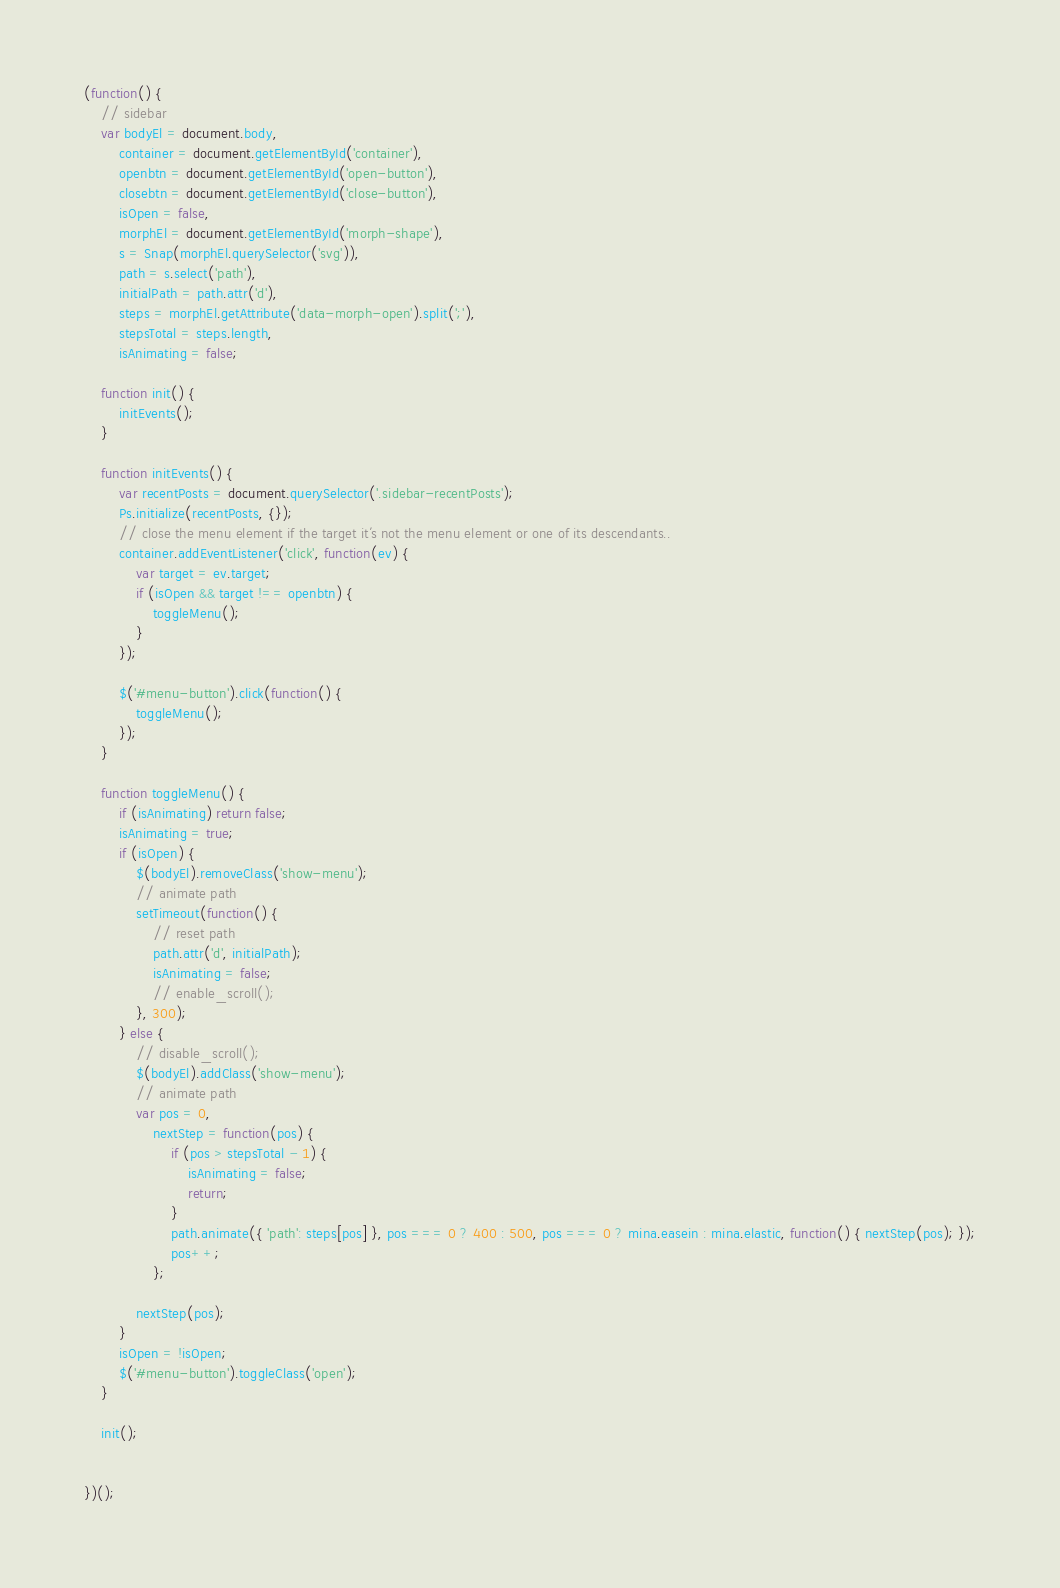<code> <loc_0><loc_0><loc_500><loc_500><_JavaScript_>(function() {
    // sidebar
    var bodyEl = document.body,
        container = document.getElementById('container'),
        openbtn = document.getElementById('open-button'),
        closebtn = document.getElementById('close-button'),
        isOpen = false,
        morphEl = document.getElementById('morph-shape'),
        s = Snap(morphEl.querySelector('svg')),
        path = s.select('path'),
        initialPath = path.attr('d'),
        steps = morphEl.getAttribute('data-morph-open').split(';'),
        stepsTotal = steps.length,
        isAnimating = false;

    function init() {
        initEvents();
    }

    function initEvents() {
        var recentPosts = document.querySelector('.sidebar-recentPosts');
        Ps.initialize(recentPosts, {});
        // close the menu element if the target it´s not the menu element or one of its descendants..
        container.addEventListener('click', function(ev) {
            var target = ev.target;
            if (isOpen && target !== openbtn) {
                toggleMenu();
            }
        });

        $('#menu-button').click(function() {
            toggleMenu();
        });
    }

    function toggleMenu() {
        if (isAnimating) return false;
        isAnimating = true;
        if (isOpen) {
            $(bodyEl).removeClass('show-menu');
            // animate path
            setTimeout(function() {
                // reset path
                path.attr('d', initialPath);
                isAnimating = false;
                // enable_scroll();
            }, 300);
        } else {
            // disable_scroll();
            $(bodyEl).addClass('show-menu');
            // animate path
            var pos = 0,
                nextStep = function(pos) {
                    if (pos > stepsTotal - 1) {
                        isAnimating = false;
                        return;
                    }
                    path.animate({ 'path': steps[pos] }, pos === 0 ? 400 : 500, pos === 0 ? mina.easein : mina.elastic, function() { nextStep(pos); });
                    pos++;
                };

            nextStep(pos);
        }
        isOpen = !isOpen;
        $('#menu-button').toggleClass('open');
    }

    init();


})();</code> 